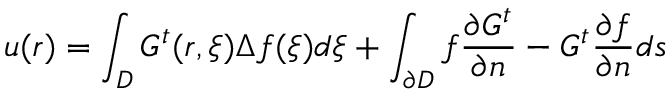<formula> <loc_0><loc_0><loc_500><loc_500>u ( r ) = \int _ { D } G ^ { t } ( r , \xi ) \Delta f ( \xi ) d \xi + \int _ { \partial D } f \frac { \partial G ^ { t } } { \partial n } - G ^ { t } \frac { \partial f } { \partial n } d s</formula> 